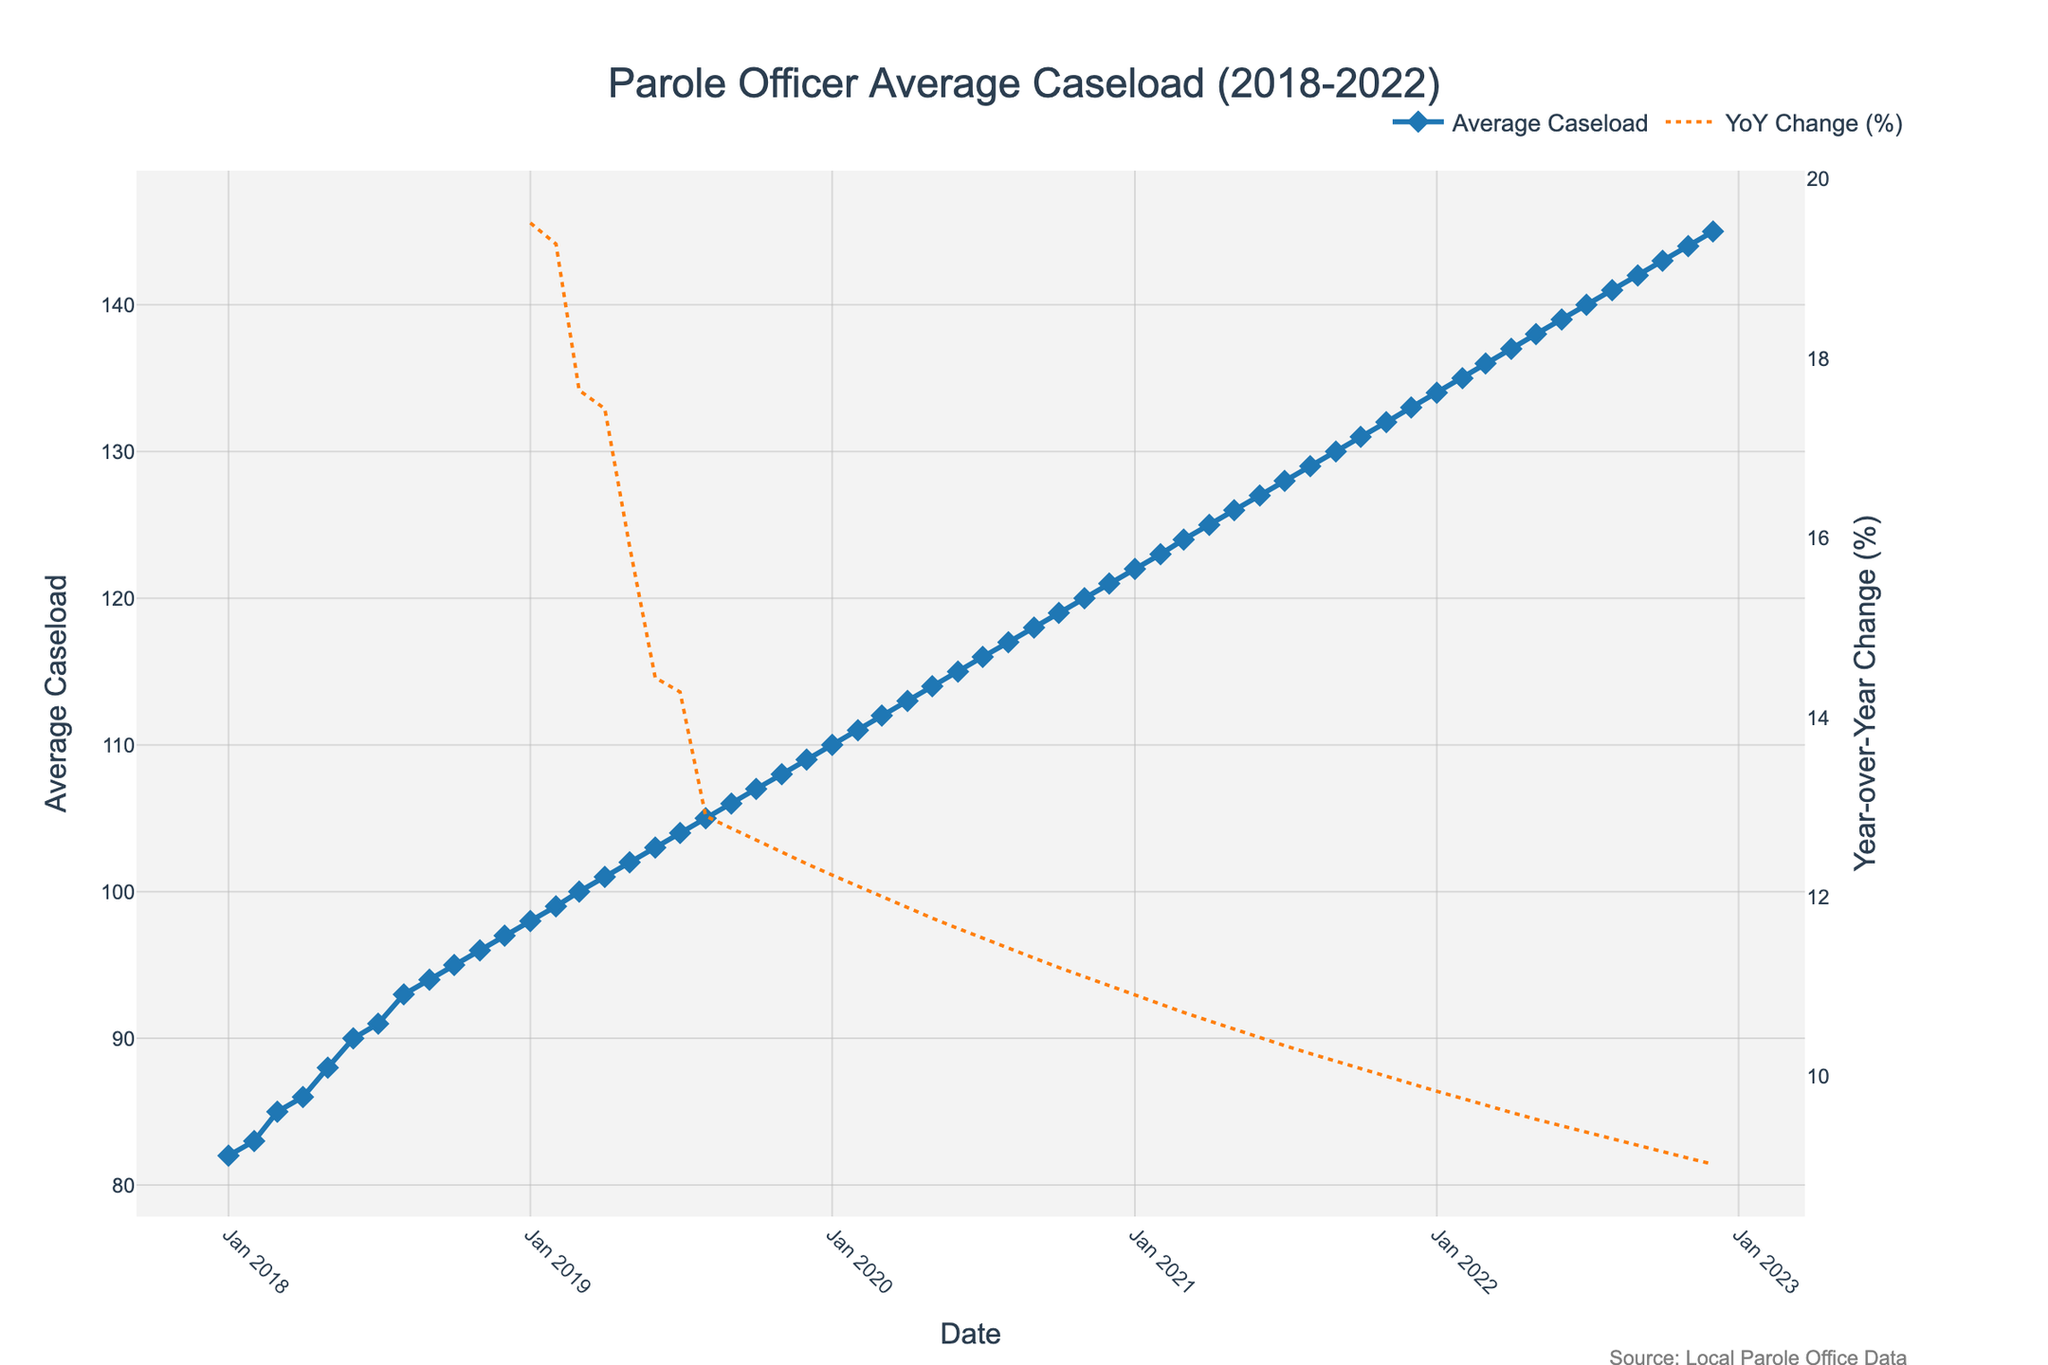What is the trend in the average caseload of parole officers from January 2018 to December 2022? By examining the line chart for the average caseload of parole officers, we can see a continuous upward trend from January 2018 to December 2022. The line slopes upward consistently, indicating an increasing average caseload over the five years.
Answer: Increasing How does the average caseload in December 2018 compare to that in December 2022? To compare the average caseload in December 2018 and December 2022, look at the data points for these two months. December 2018 shows an average caseload of 97, while December 2022 shows 145. Clearly, the caseload increased from 2018 to 2022.
Answer: Increased What is the percentage change in average caseload from January 2018 to January 2022? Calculate the percentage change using the formula [(Value in Jan 2022 - Value in Jan 2018) / Value in Jan 2018] * 100. Values are 134 in January 2022 and 82 in January 2018. Plugging these values into the formula gives [(134 - 82) / 82] * 100 = 63.41%.
Answer: 63.41% Which month had the highest Year-over-Year (YoY) change percentage, and what was the value? Check the secondary y-axis (right side) which represents the YoY change percentage. Look for the month with the peak value on this axis. The highest peak occurs in January 2022 with a YoY change percentage of approximately 10.20%.
Answer: January 2022, 10.20% Is there any month where the average caseload decreased year-over-year? Examine the secondary y-axis (right side) which represents the YoY change percentage. Look for any negative values indicating a decrease. There are no negative values, implying that the average caseload did not decrease year-over-year in any month.
Answer: No Between which two consecutive months in 2020 was the largest increase in average caseload observed? To identify the largest increase between two consecutive months in 2020, compare the differences month by month. From April 2020 to May 2020, the caseload increased from 113 to 114, so the difference is 1. Continue this method and find that the largest difference is from May 2020 to June 2020 (114 to 115, difference of 1, similar to other months). Thus, no significantly large increase stands out for 2020.
Answer: N/A What is the Month with the lowest average caseload within the given data range? To find the month with the lowest average caseload, look for the lowest data point in the chart for the average caseload line. January 2018 shows the lowest average caseload of 82.
Answer: January 2018, 82 